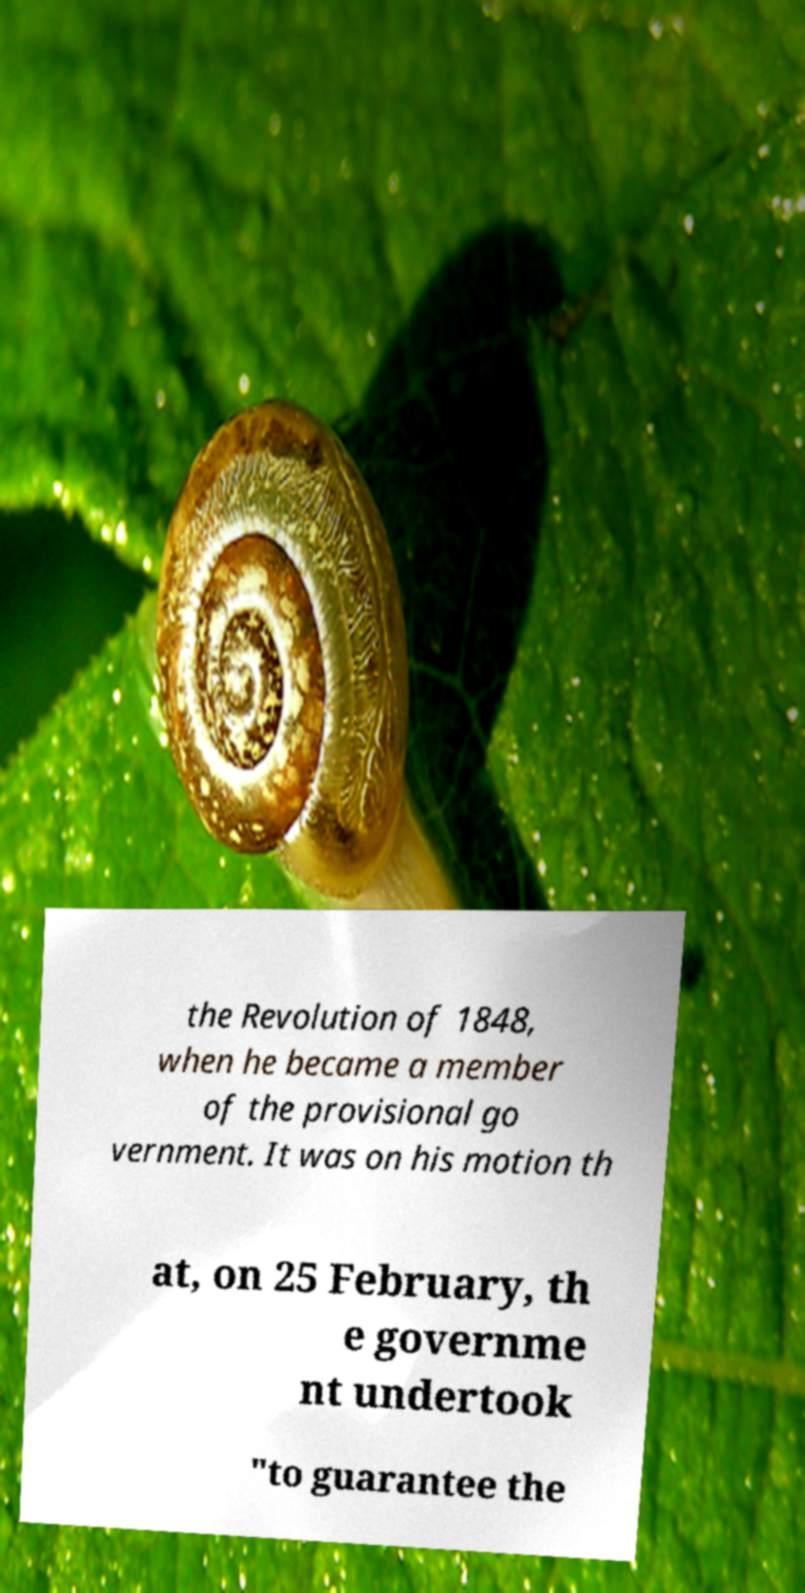Could you extract and type out the text from this image? the Revolution of 1848, when he became a member of the provisional go vernment. It was on his motion th at, on 25 February, th e governme nt undertook "to guarantee the 